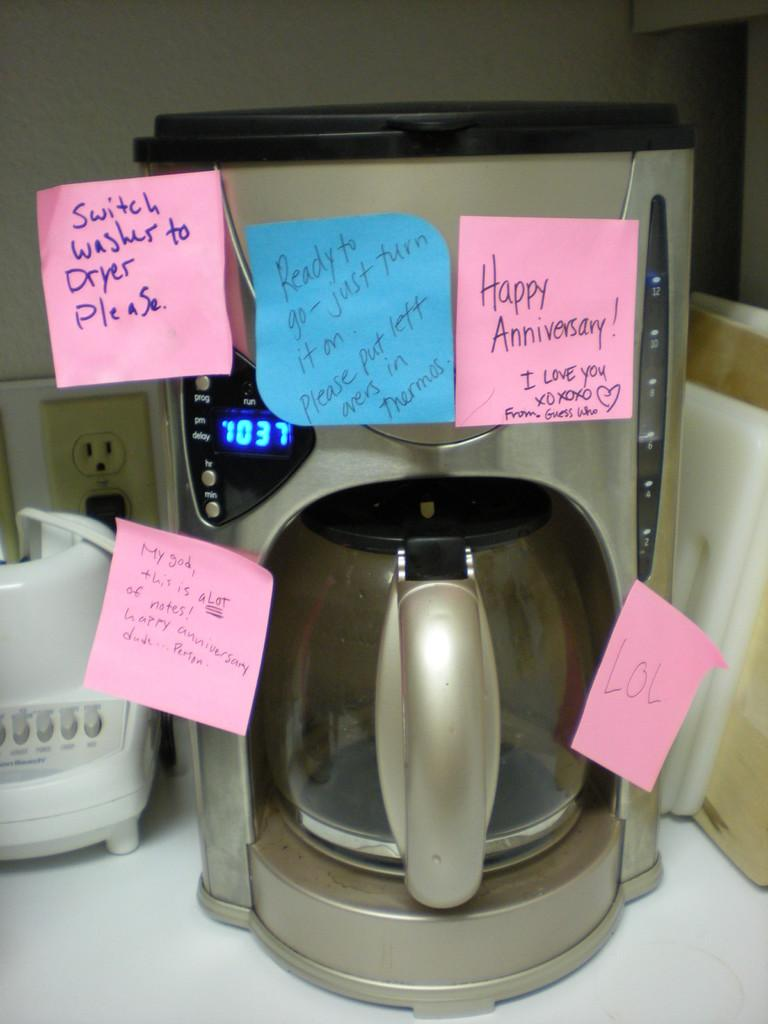Provide a one-sentence caption for the provided image. Numerous post it notes are stuck to a coffee maker, one saying Happy Anniversary and the other giving instructions for tasks. 